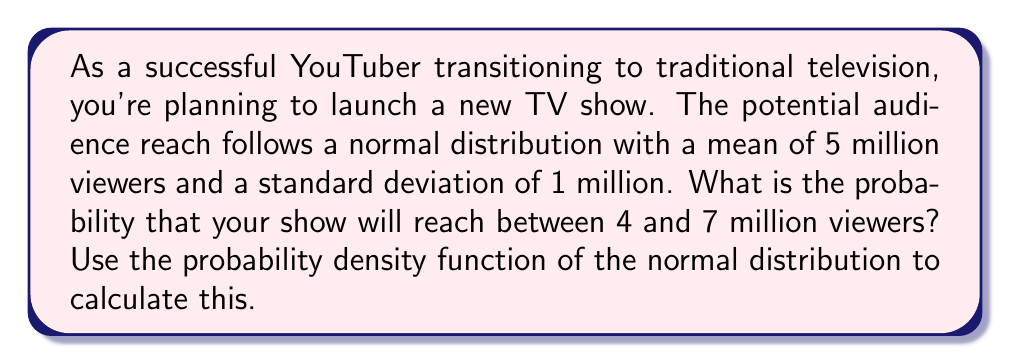Could you help me with this problem? To solve this problem, we'll use the probability density function (PDF) of the normal distribution and integrate it over the given range. Here's a step-by-step approach:

1) The PDF of the normal distribution is given by:

   $$f(x) = \frac{1}{\sigma\sqrt{2\pi}} e^{-\frac{(x-\mu)^2}{2\sigma^2}}$$

   where $\mu$ is the mean and $\sigma$ is the standard deviation.

2) In this case, $\mu = 5$ million and $\sigma = 1$ million.

3) We need to find:

   $$P(4 \leq X \leq 7) = \int_{4}^{7} f(x) dx$$

4) To simplify the calculation, we'll use the standard normal distribution by applying the z-score transformation:

   $$z = \frac{x - \mu}{\sigma}$$

5) The limits of integration in terms of z-scores are:

   For x = 4: $z = \frac{4 - 5}{1} = -1$
   For x = 7: $z = \frac{7 - 5}{1} = 2$

6) Now we can rewrite our probability as:

   $$P(-1 \leq Z \leq 2) = \Phi(2) - \Phi(-1)$$

   where $\Phi(z)$ is the cumulative distribution function of the standard normal distribution.

7) Using a standard normal table or calculator:

   $\Phi(2) \approx 0.9772$
   $\Phi(-1) \approx 0.1587$

8) Therefore:

   $$P(4 \leq X \leq 7) = 0.9772 - 0.1587 = 0.8185$$
Answer: The probability that the TV show will reach between 4 and 7 million viewers is approximately 0.8185 or 81.85%. 